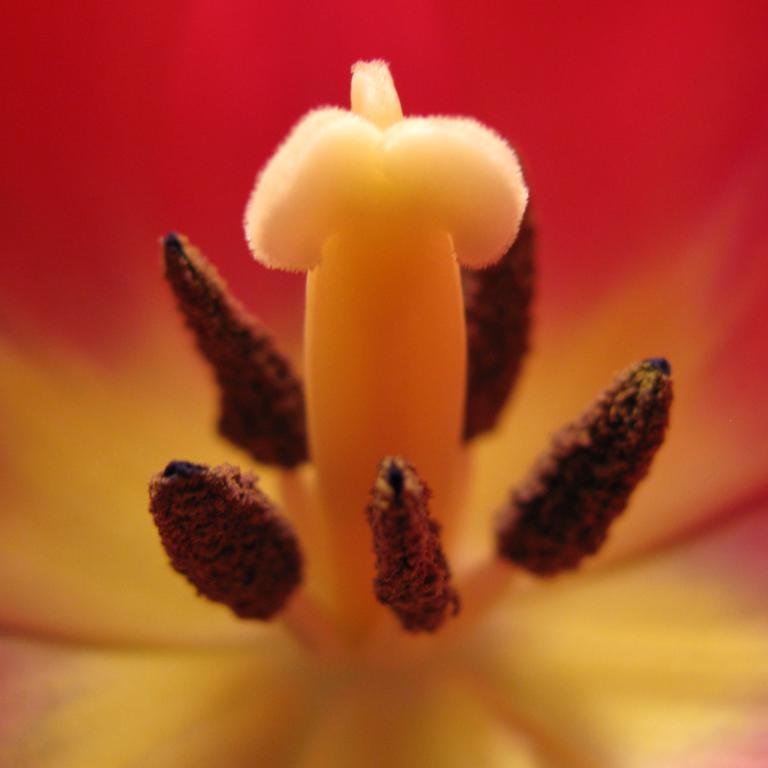Please provide a concise description of this image. In this picture we can observe a flower. This is a macro photograph of a flower which is in brown and yellow color. The background is in red color. 